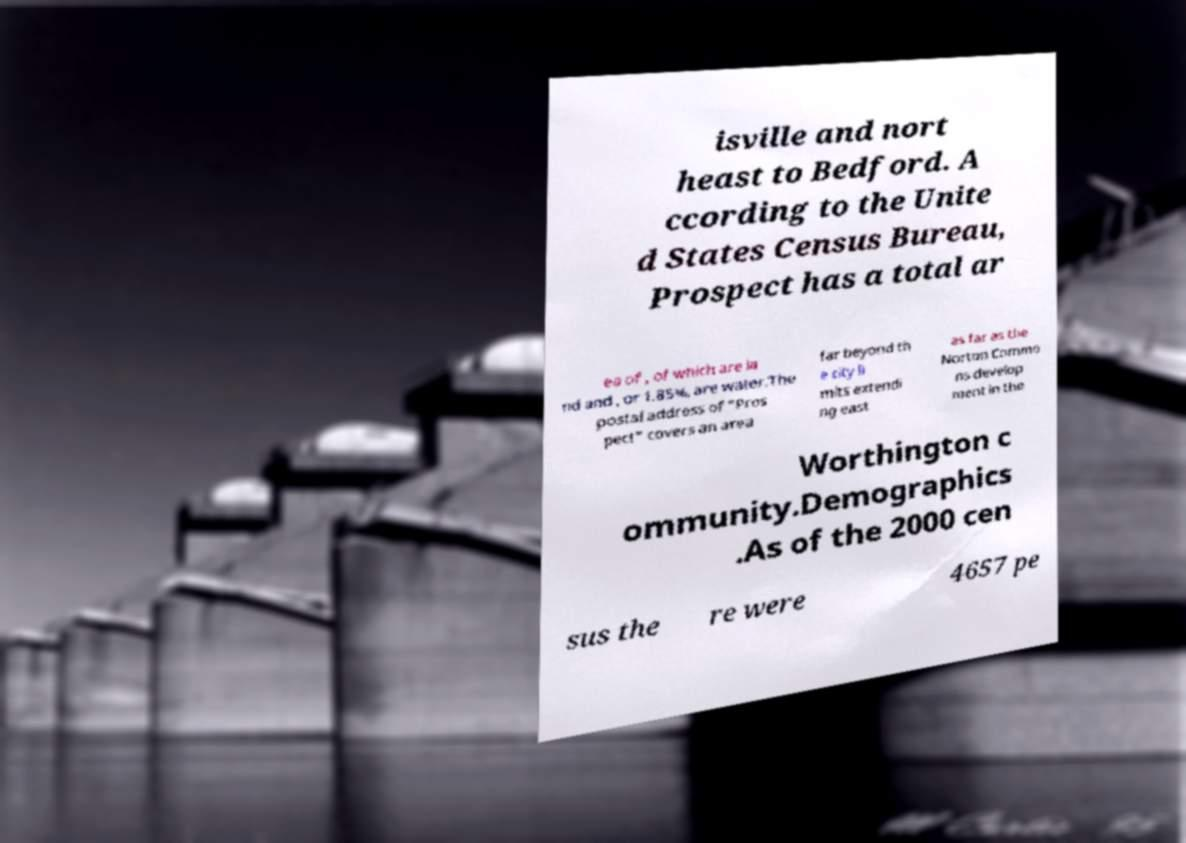For documentation purposes, I need the text within this image transcribed. Could you provide that? isville and nort heast to Bedford. A ccording to the Unite d States Census Bureau, Prospect has a total ar ea of , of which are la nd and , or 1.85%, are water.The postal address of "Pros pect" covers an area far beyond th e city li mits extendi ng east as far as the Norton Commo ns develop ment in the Worthington c ommunity.Demographics .As of the 2000 cen sus the re were 4657 pe 